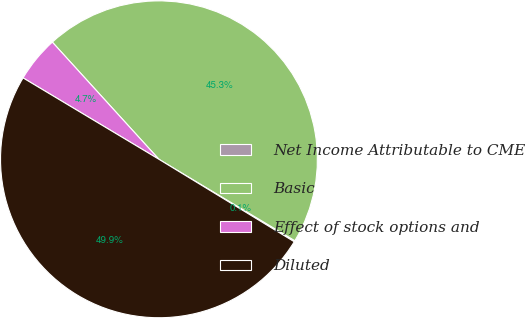Convert chart to OTSL. <chart><loc_0><loc_0><loc_500><loc_500><pie_chart><fcel>Net Income Attributable to CME<fcel>Basic<fcel>Effect of stock options and<fcel>Diluted<nl><fcel>0.12%<fcel>45.34%<fcel>4.66%<fcel>49.88%<nl></chart> 